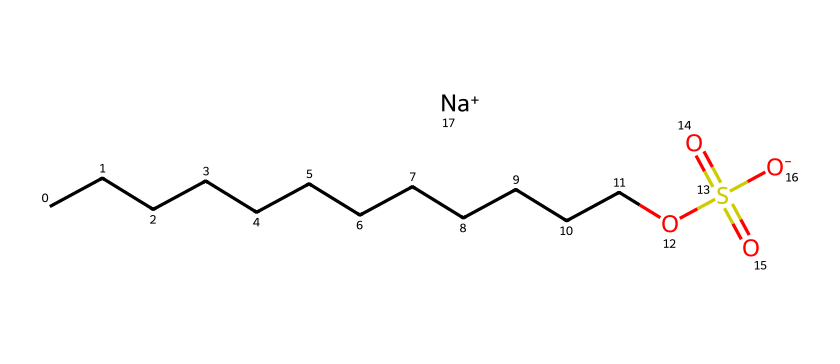What is the total number of carbon atoms in sodium lauryl sulfate? The SMILES representation shows a long chain of carbon atoms (CCCCCCCCCCCC), which indicates there are 12 carbon atoms in total.
Answer: 12 How many oxygen atoms are present in the chemical structure? In the SMILES, there are three oxygen atoms indicated by "O" in "OS(=O)(=O)[O-]", showing that there are 3 oxygen atoms in the chemical structure.
Answer: 3 What is the role of sodium in sodium lauryl sulfate? In this structure, sodium (Na+) acts as a counter ion to balance the negative charge of the sulfate group ("OS(=O)(=O)[O-]"), making the compound a salt.
Answer: counter ion What type of surfactant is sodium lauryl sulfate? Sodium lauryl sulfate has a sulfate group in its structure and exhibits properties of anionic surfactants, which are characterized by a negatively charged hydrophilic head.
Answer: anionic How does the long carbon chain influence the properties of sodium lauryl sulfate? The long carbon chain (CCCCCCCCCCCC) contributes to the hydrophobic tail of the molecule, which allows it to interact effectively with oils and grease while the sulfate group allows it to dissolve in water, making it an effective detergent.
Answer: hydrophobic What do the sulfate groups in sodium lauryl sulfate signify? The presence of the sulfate (SO4) functional group indicates that sodium lauryl sulfate has surfactant properties, allowing it to reduce surface tension in water, enhancing its cleaning effectiveness.
Answer: surfactant properties How does the sodium cation affect the solubility of sodium lauryl sulfate? The sodium cation provides ionic character, increasing the solubility of sodium lauryl sulfate in water due to the electrostatic interaction with water molecules.
Answer: increases solubility 